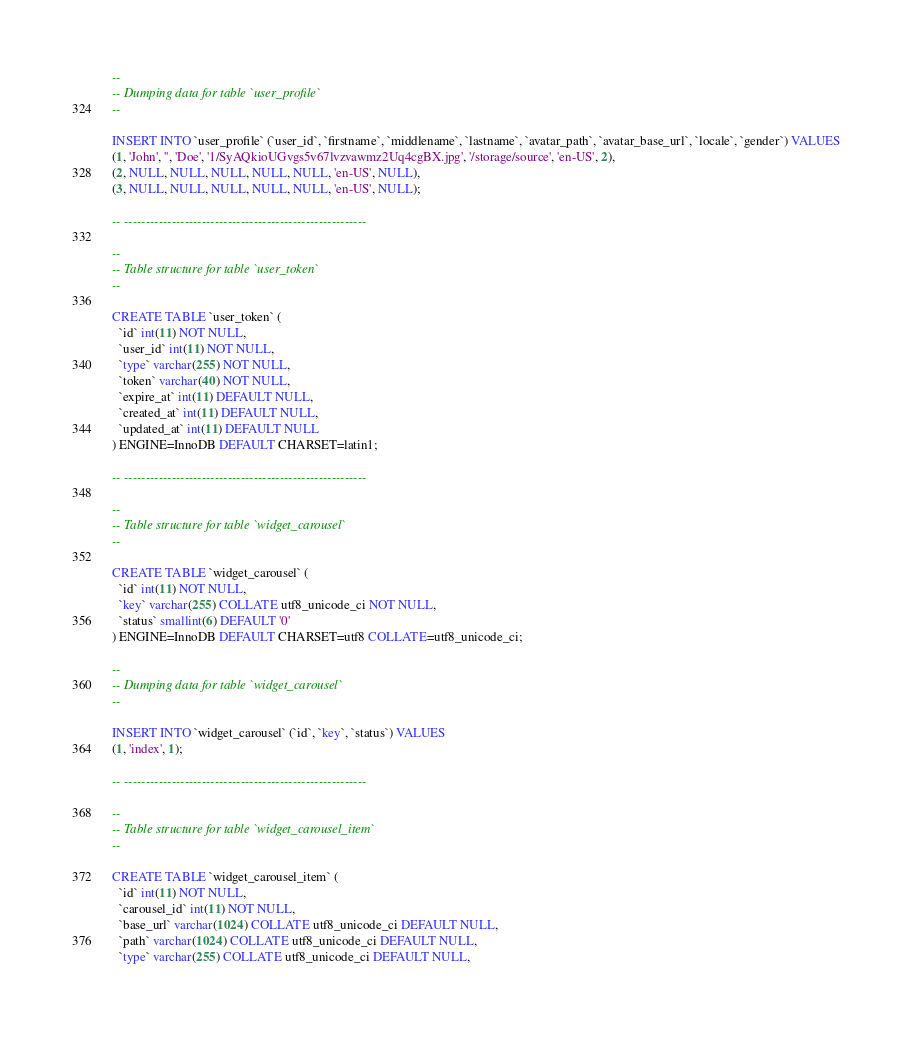<code> <loc_0><loc_0><loc_500><loc_500><_SQL_>
--
-- Dumping data for table `user_profile`
--

INSERT INTO `user_profile` (`user_id`, `firstname`, `middlename`, `lastname`, `avatar_path`, `avatar_base_url`, `locale`, `gender`) VALUES
(1, 'John', '', 'Doe', '1/SyAQkioUGvgs5v67lvzvawmz2Uq4cgBX.jpg', '/storage/source', 'en-US', 2),
(2, NULL, NULL, NULL, NULL, NULL, 'en-US', NULL),
(3, NULL, NULL, NULL, NULL, NULL, 'en-US', NULL);

-- --------------------------------------------------------

--
-- Table structure for table `user_token`
--

CREATE TABLE `user_token` (
  `id` int(11) NOT NULL,
  `user_id` int(11) NOT NULL,
  `type` varchar(255) NOT NULL,
  `token` varchar(40) NOT NULL,
  `expire_at` int(11) DEFAULT NULL,
  `created_at` int(11) DEFAULT NULL,
  `updated_at` int(11) DEFAULT NULL
) ENGINE=InnoDB DEFAULT CHARSET=latin1;

-- --------------------------------------------------------

--
-- Table structure for table `widget_carousel`
--

CREATE TABLE `widget_carousel` (
  `id` int(11) NOT NULL,
  `key` varchar(255) COLLATE utf8_unicode_ci NOT NULL,
  `status` smallint(6) DEFAULT '0'
) ENGINE=InnoDB DEFAULT CHARSET=utf8 COLLATE=utf8_unicode_ci;

--
-- Dumping data for table `widget_carousel`
--

INSERT INTO `widget_carousel` (`id`, `key`, `status`) VALUES
(1, 'index', 1);

-- --------------------------------------------------------

--
-- Table structure for table `widget_carousel_item`
--

CREATE TABLE `widget_carousel_item` (
  `id` int(11) NOT NULL,
  `carousel_id` int(11) NOT NULL,
  `base_url` varchar(1024) COLLATE utf8_unicode_ci DEFAULT NULL,
  `path` varchar(1024) COLLATE utf8_unicode_ci DEFAULT NULL,
  `type` varchar(255) COLLATE utf8_unicode_ci DEFAULT NULL,</code> 